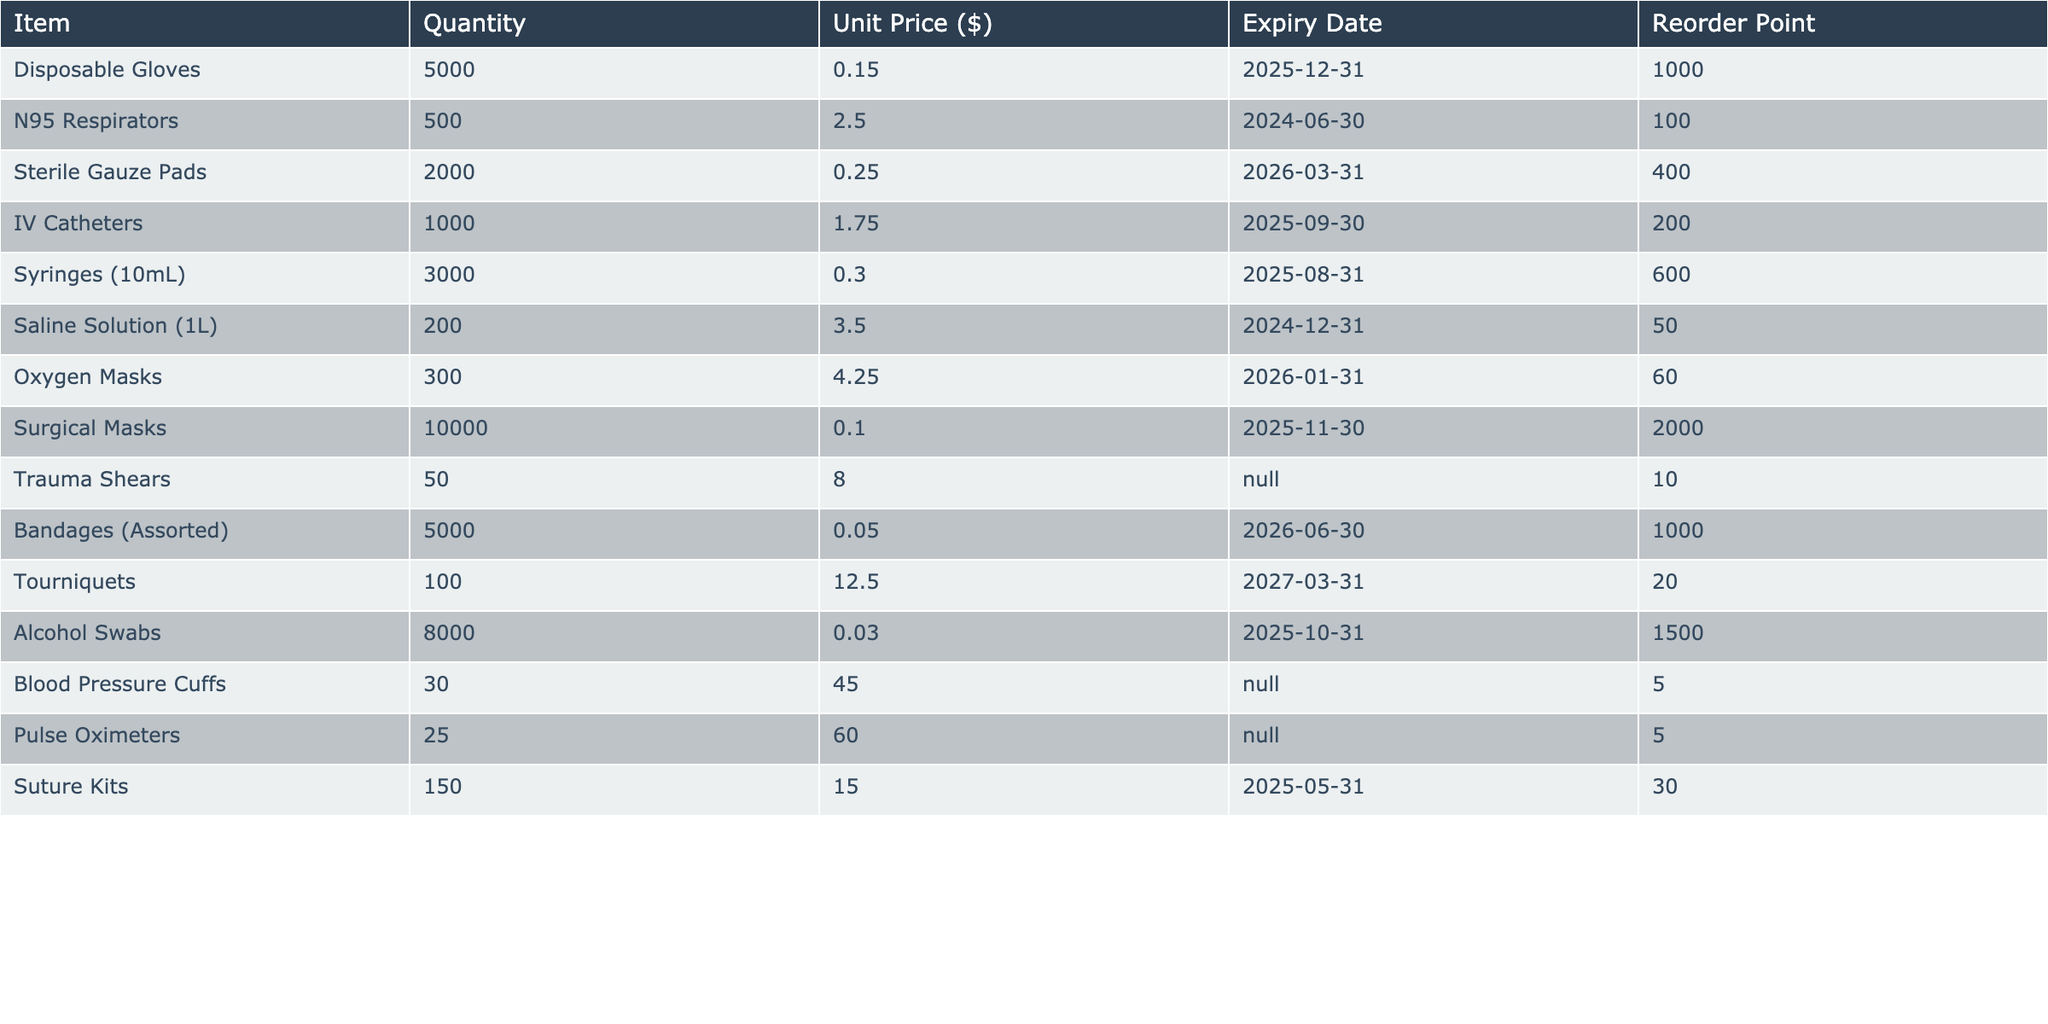What is the total quantity of Disposable Gloves in the inventory? The table shows the item "Disposable Gloves" with a quantity of 5000 listed. Therefore, the total quantity is directly from the table.
Answer: 5000 How many units of N95 Respirators are available? The quantity of N95 Respirators is found in the table which states there are 500 units.
Answer: 500 Is the quantity of Oxygen Masks less than the Reorder Point? From the table, the available quantity of Oxygen Masks is 300, and the reorder point is 60. Since 300 is greater than 60, the statement is false.
Answer: No What is the unit price for Saline Solution? The table lists the unit price for Saline Solution (1L) as $3.50.
Answer: 3.50 What is the average unit price of all items listed in the inventory? To find the average unit price, sum all the unit prices: (0.15 + 2.50 + 0.25 + 1.75 + 0.30 + 3.50 + 4.25 + 0.10 + 8.00 + 0.05 + 12.50 + 0.03 + 45.00 + 60.00 + 15.00) = 138.75. There are 15 items, so the average unit price is 138.75 / 15 = 9.25.
Answer: 9.25 How many items in the inventory have a Reorder Point greater than 1000? From the table, the items with a Reorder Point greater than 1000 are Disposable Gloves (1000), Bandages (Assorted) (1000), and Surgical Masks (2000). Therefore, there are 3 items that meet this criterion.
Answer: 3 What is the total quantity of medical supplies that have an expiry date in the year 2024? The items with expiry dates in 2024 are N95 Respirators (500 units) and Saline Solution (1L) (200 units). Adding these quantities gives us 500 + 200 = 700 units.
Answer: 700 Are there any items in the inventory with no expiry date listed? The table shows two items: Trauma Shears and Blood Pressure Cuffs that have "N/A" listed for the expiry date, confirming at least some items have no recorded expiry date.
Answer: Yes What is the difference in price between the most expensive and least expensive item? Reviewing the table, the most expensive item is Blood Pressure Cuffs at $45.00, and the least expensive item is Alcohol Swabs at $0.03. The difference is calculated as 45.00 - 0.03 = 44.97.
Answer: 44.97 How many total units of medical supplies are scheduled to expire before 2025? The items expiring before 2025 are N95 Respirators (500), Saline Solution (1L) (200), and Suture Kits (150). The total quantity is 500 + 200 + 150 = 850 units.
Answer: 850 